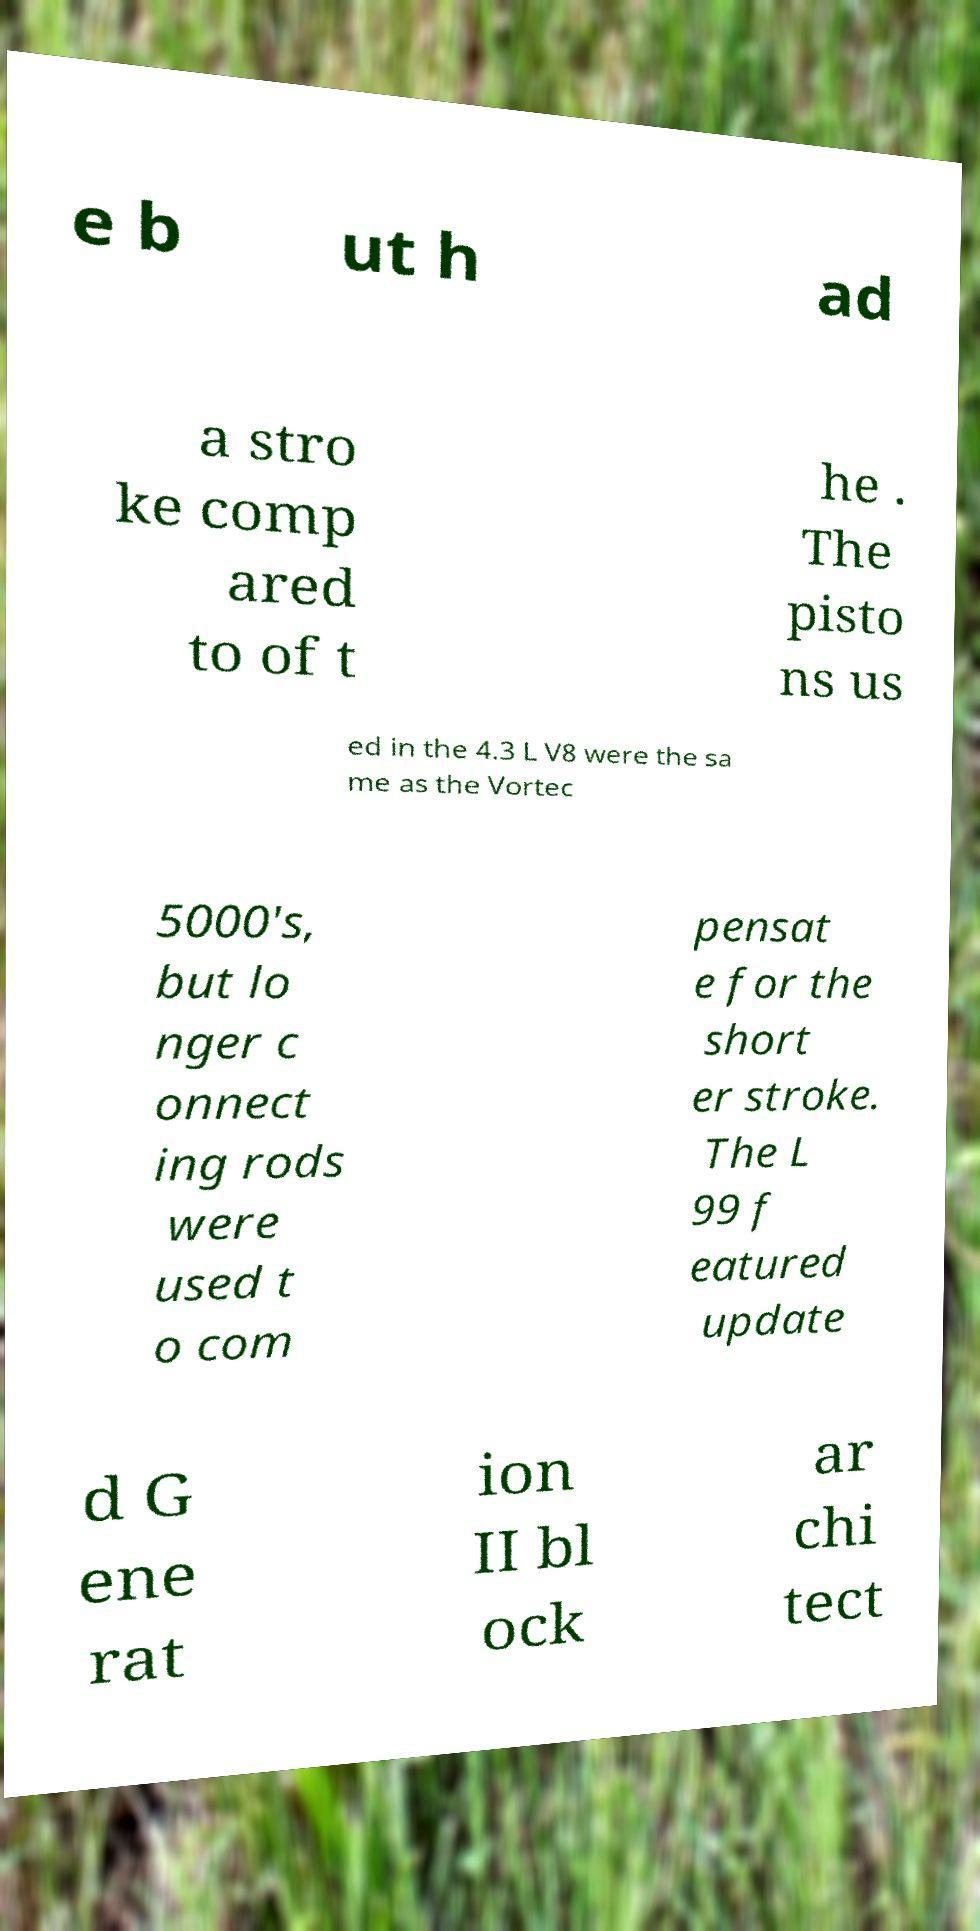Please identify and transcribe the text found in this image. e b ut h ad a stro ke comp ared to of t he . The pisto ns us ed in the 4.3 L V8 were the sa me as the Vortec 5000's, but lo nger c onnect ing rods were used t o com pensat e for the short er stroke. The L 99 f eatured update d G ene rat ion II bl ock ar chi tect 